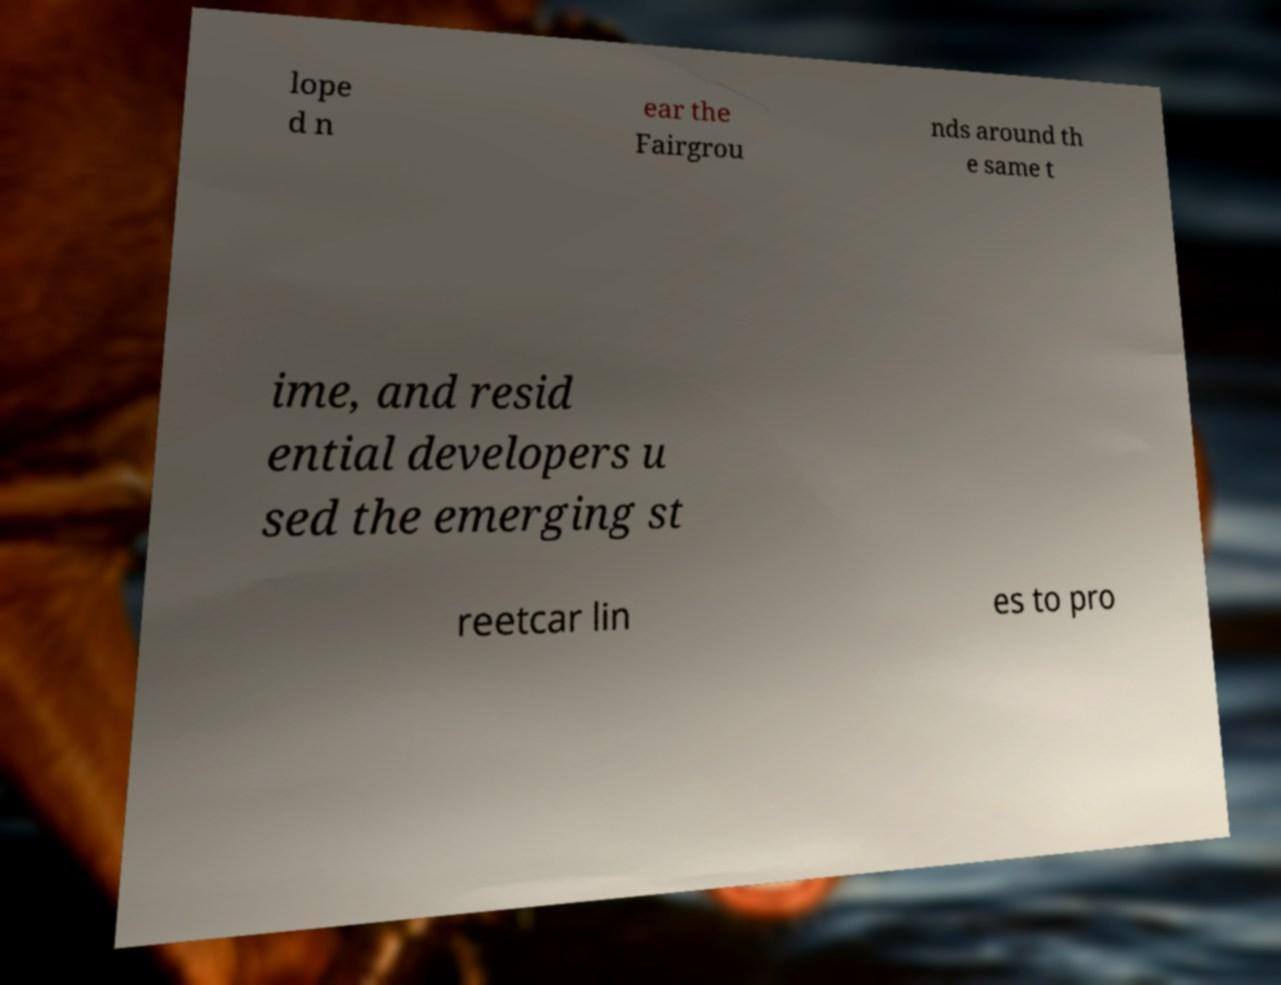Could you assist in decoding the text presented in this image and type it out clearly? lope d n ear the Fairgrou nds around th e same t ime, and resid ential developers u sed the emerging st reetcar lin es to pro 